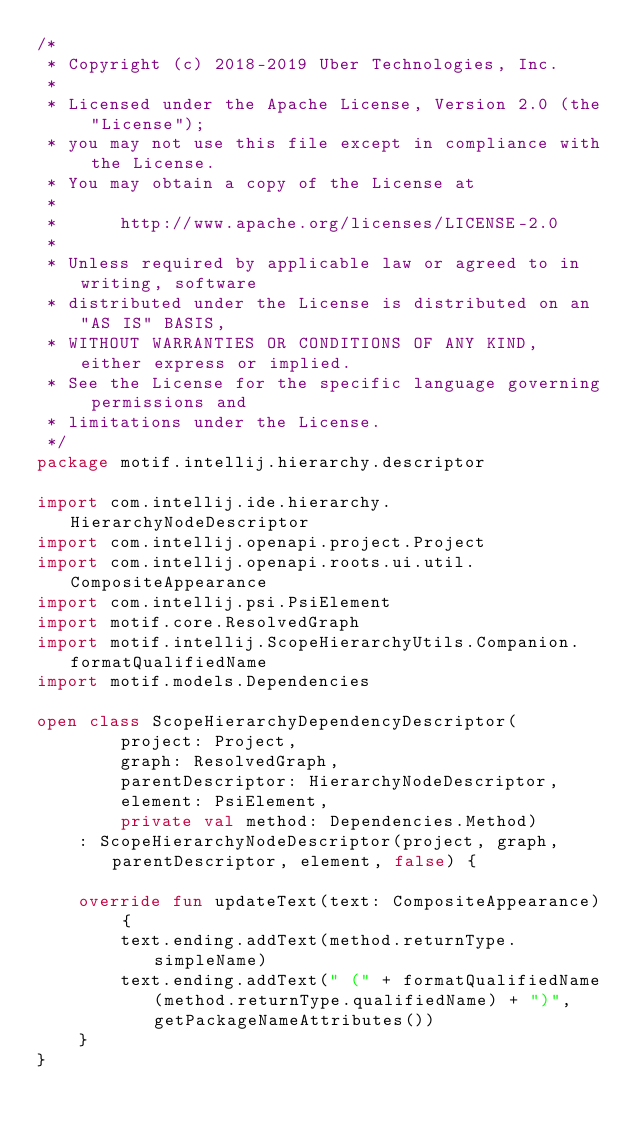<code> <loc_0><loc_0><loc_500><loc_500><_Kotlin_>/*
 * Copyright (c) 2018-2019 Uber Technologies, Inc.
 *
 * Licensed under the Apache License, Version 2.0 (the "License");
 * you may not use this file except in compliance with the License.
 * You may obtain a copy of the License at
 *
 *      http://www.apache.org/licenses/LICENSE-2.0
 *
 * Unless required by applicable law or agreed to in writing, software
 * distributed under the License is distributed on an "AS IS" BASIS,
 * WITHOUT WARRANTIES OR CONDITIONS OF ANY KIND, either express or implied.
 * See the License for the specific language governing permissions and
 * limitations under the License.
 */
package motif.intellij.hierarchy.descriptor

import com.intellij.ide.hierarchy.HierarchyNodeDescriptor
import com.intellij.openapi.project.Project
import com.intellij.openapi.roots.ui.util.CompositeAppearance
import com.intellij.psi.PsiElement
import motif.core.ResolvedGraph
import motif.intellij.ScopeHierarchyUtils.Companion.formatQualifiedName
import motif.models.Dependencies

open class ScopeHierarchyDependencyDescriptor(
        project: Project,
        graph: ResolvedGraph,
        parentDescriptor: HierarchyNodeDescriptor,
        element: PsiElement,
        private val method: Dependencies.Method)
    : ScopeHierarchyNodeDescriptor(project, graph, parentDescriptor, element, false) {

    override fun updateText(text: CompositeAppearance) {
        text.ending.addText(method.returnType.simpleName)
        text.ending.addText(" (" + formatQualifiedName(method.returnType.qualifiedName) + ")", getPackageNameAttributes())
    }
}

</code> 